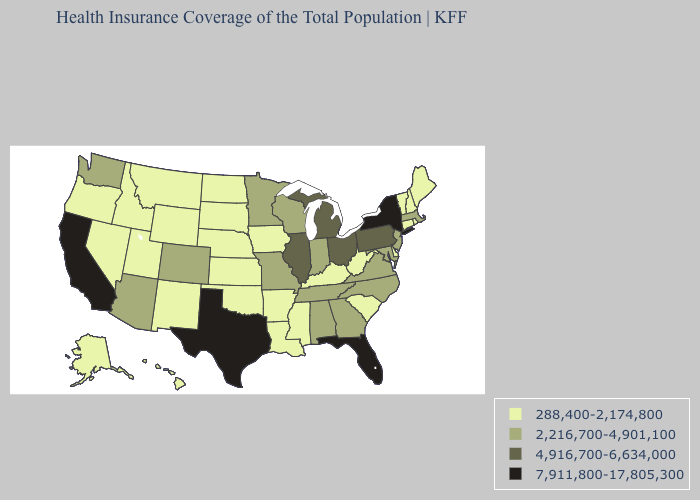Name the states that have a value in the range 288,400-2,174,800?
Keep it brief. Alaska, Arkansas, Connecticut, Delaware, Hawaii, Idaho, Iowa, Kansas, Kentucky, Louisiana, Maine, Mississippi, Montana, Nebraska, Nevada, New Hampshire, New Mexico, North Dakota, Oklahoma, Oregon, Rhode Island, South Carolina, South Dakota, Utah, Vermont, West Virginia, Wyoming. What is the value of Washington?
Write a very short answer. 2,216,700-4,901,100. What is the highest value in the West ?
Short answer required. 7,911,800-17,805,300. Does Illinois have the highest value in the MidWest?
Quick response, please. Yes. Name the states that have a value in the range 288,400-2,174,800?
Give a very brief answer. Alaska, Arkansas, Connecticut, Delaware, Hawaii, Idaho, Iowa, Kansas, Kentucky, Louisiana, Maine, Mississippi, Montana, Nebraska, Nevada, New Hampshire, New Mexico, North Dakota, Oklahoma, Oregon, Rhode Island, South Carolina, South Dakota, Utah, Vermont, West Virginia, Wyoming. Name the states that have a value in the range 7,911,800-17,805,300?
Quick response, please. California, Florida, New York, Texas. What is the value of Louisiana?
Give a very brief answer. 288,400-2,174,800. Is the legend a continuous bar?
Short answer required. No. Is the legend a continuous bar?
Short answer required. No. What is the value of South Dakota?
Short answer required. 288,400-2,174,800. What is the value of Montana?
Short answer required. 288,400-2,174,800. Does Iowa have the highest value in the MidWest?
Give a very brief answer. No. Which states have the lowest value in the USA?
Quick response, please. Alaska, Arkansas, Connecticut, Delaware, Hawaii, Idaho, Iowa, Kansas, Kentucky, Louisiana, Maine, Mississippi, Montana, Nebraska, Nevada, New Hampshire, New Mexico, North Dakota, Oklahoma, Oregon, Rhode Island, South Carolina, South Dakota, Utah, Vermont, West Virginia, Wyoming. What is the value of California?
Concise answer only. 7,911,800-17,805,300. 